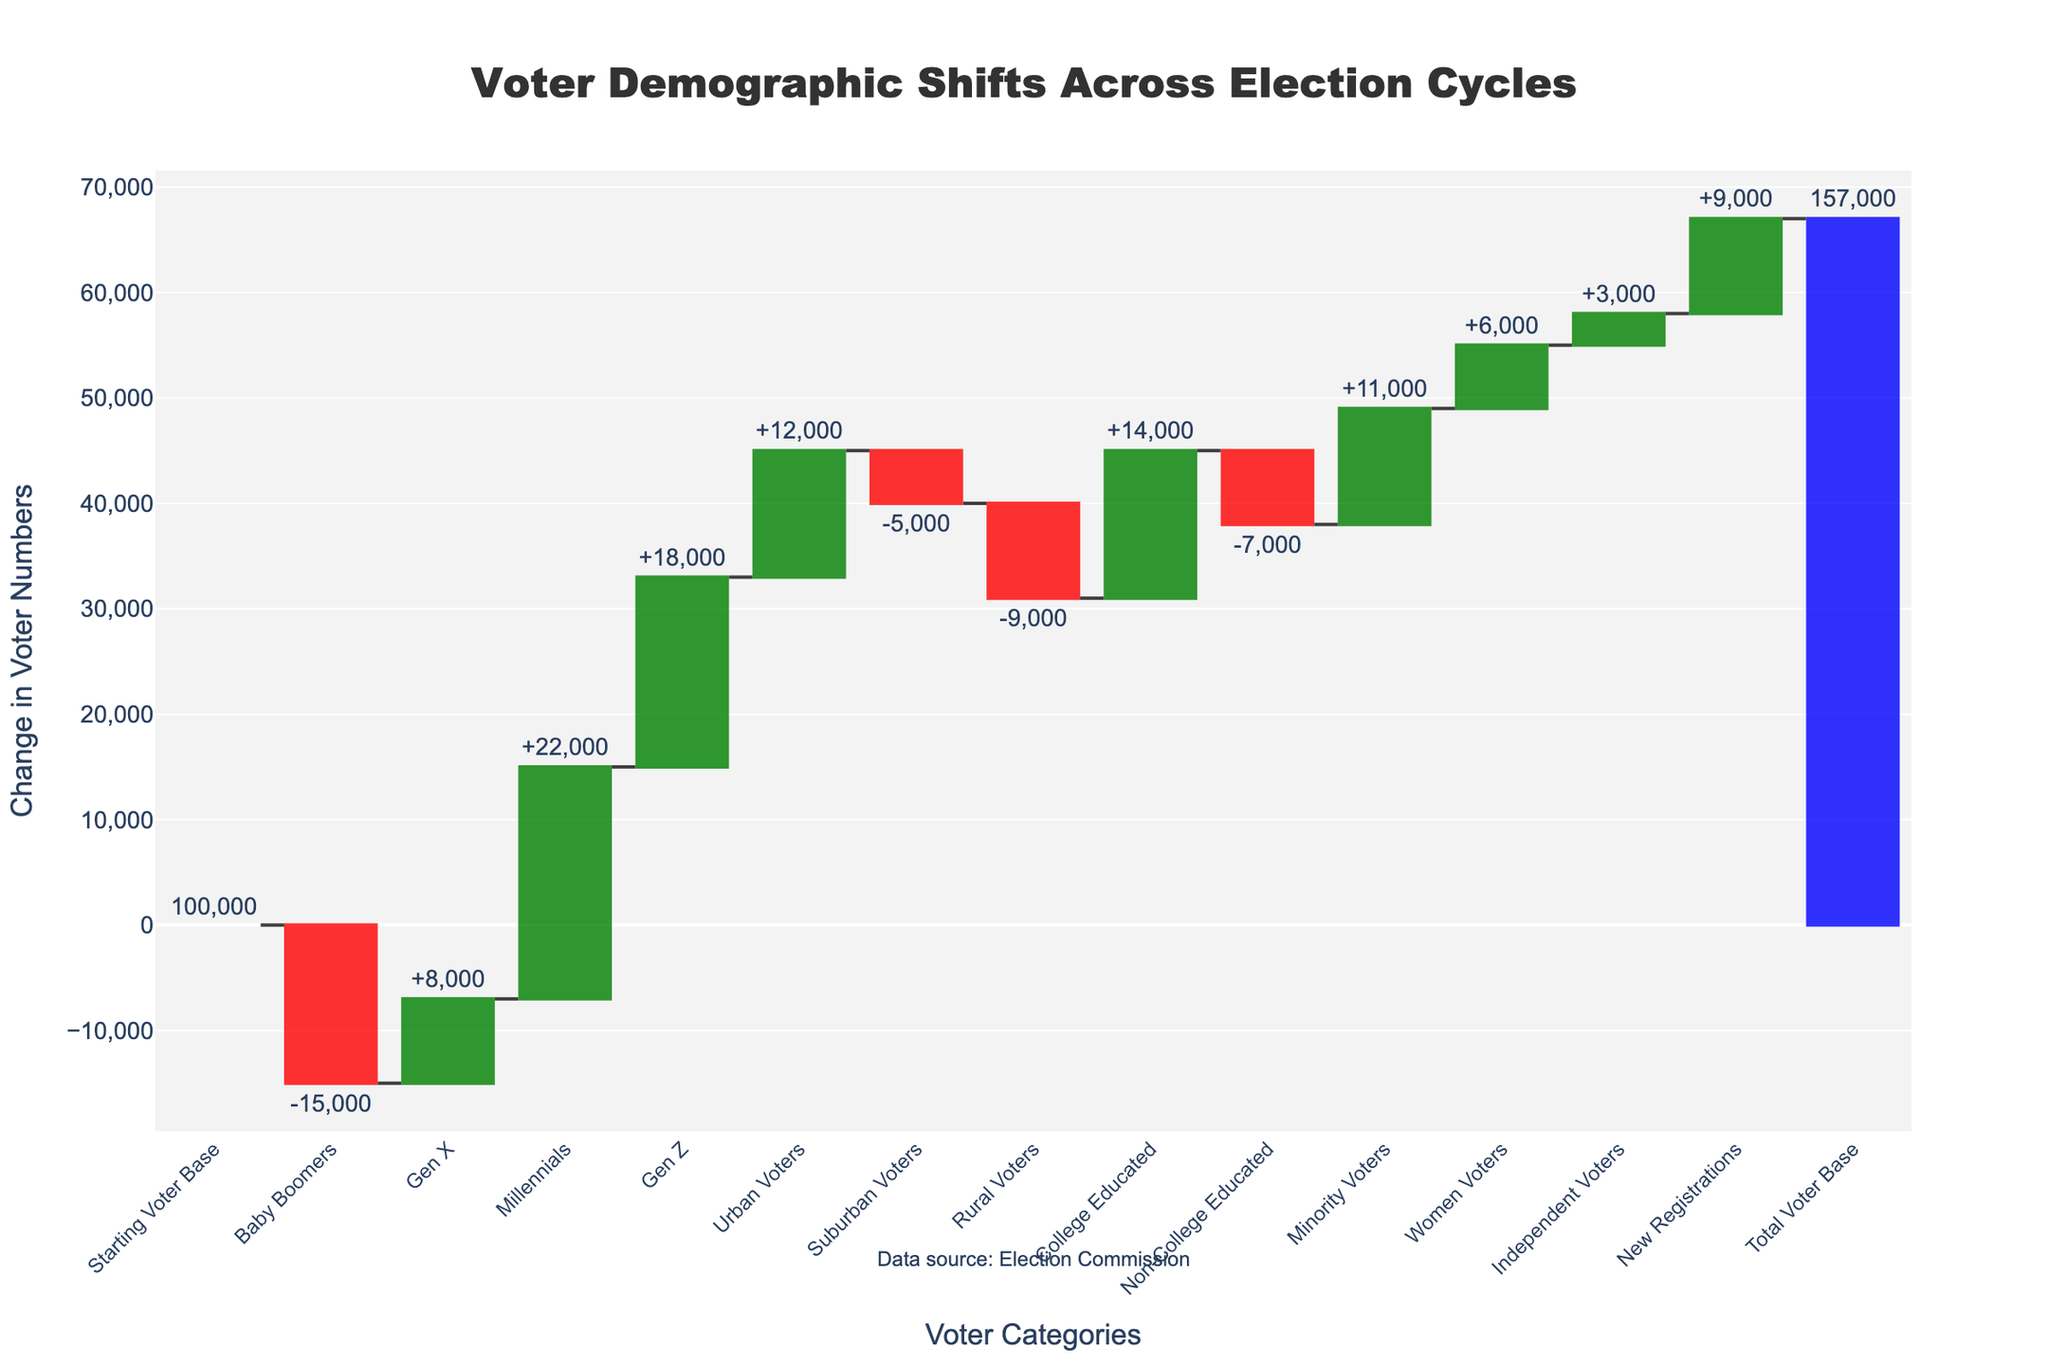what is the value for Starting Voter Base? The Starting Voter Base is the initial value given in the chart, which is 100,000. This can be directly read from the chart, where the value is displayed outside the bar.
Answer: 100,000 What group had the largest increase in voter base? By observing the height of the bars and their values, we see that Millennials had the largest increase, with a value of +22,000.
Answer: Millennials How many total groups showed a negative change in voter base? In the chart, red bars represent groups with negative changes. Counting these bars, we see that there are five groups with a decrease: Baby Boomers, Suburban Voters, Rural Voters, and Non-College Educated.
Answer: 5 What is the cumulative change contributed by Gen Z and Urban Voters combined? Gen Z contributed +18,000 and Urban Voters contributed +12,000. Adding these values together: 18,000 + 12,000 = 30,000.
Answer: 30,000 How many groups had an increase greater than 10,000? The bars indicating increases greater than 10,000 are those for Millennials (+22,000), Gen Z (+18,000), Urban Voters (+12,000), College Educated (+14,000), and Minority Voters (+11,000). There are five such groups.
Answer: 5 Which group had the smallest negative change and what is its value? Among the red bars, the smallest negative change is for Suburban Voters, which is -5,000.
Answer: Suburban Voters, -5,000 Compare the total change in voter base between College Educated and Non-College Educated voters. College Educated voters had an increase of +14,000, while Non-College Educated voters had a decrease of -7,000. The net difference is 14,000 - (-7,000) = 21,000.
Answer: 21,000 What is the total voter base after accounting for all changes? The total voter base after all changes is shown as the last value in the chart, which is 157,000.
Answer: 157,000 How did the base change contributed by Women Voters compare to Independent Voters? Women Voters contributed +6,000, while Independent Voters contributed +3,000. Women Voters had a change that was twice that of Independent Voters.
Answer: Twice How much did Minority Voters contribute to the total voter base change? The increase from Minority Voters is +11,000, as directly shown on the chart outside the bar.
Answer: 11,000 